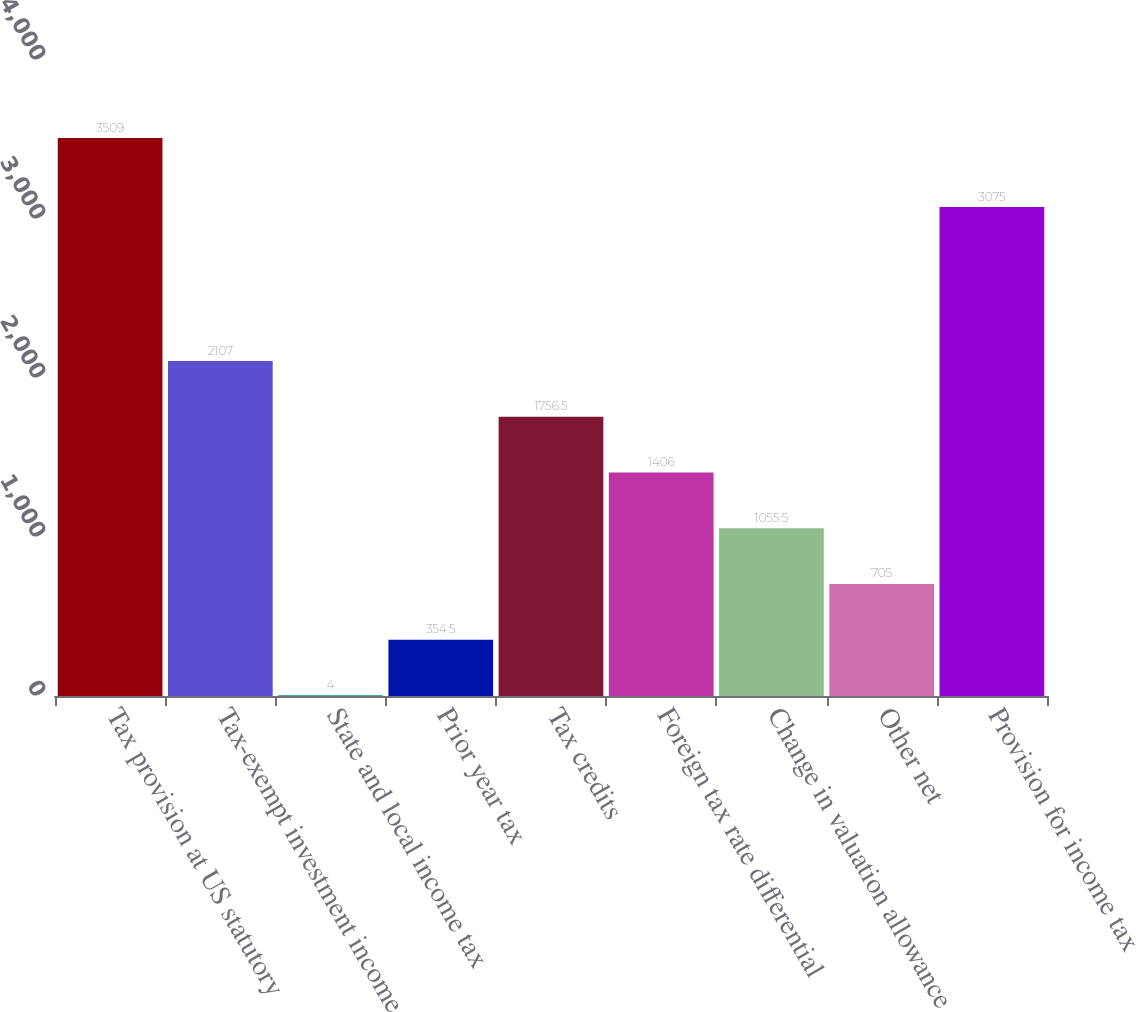<chart> <loc_0><loc_0><loc_500><loc_500><bar_chart><fcel>Tax provision at US statutory<fcel>Tax-exempt investment income<fcel>State and local income tax<fcel>Prior year tax<fcel>Tax credits<fcel>Foreign tax rate differential<fcel>Change in valuation allowance<fcel>Other net<fcel>Provision for income tax<nl><fcel>3509<fcel>2107<fcel>4<fcel>354.5<fcel>1756.5<fcel>1406<fcel>1055.5<fcel>705<fcel>3075<nl></chart> 